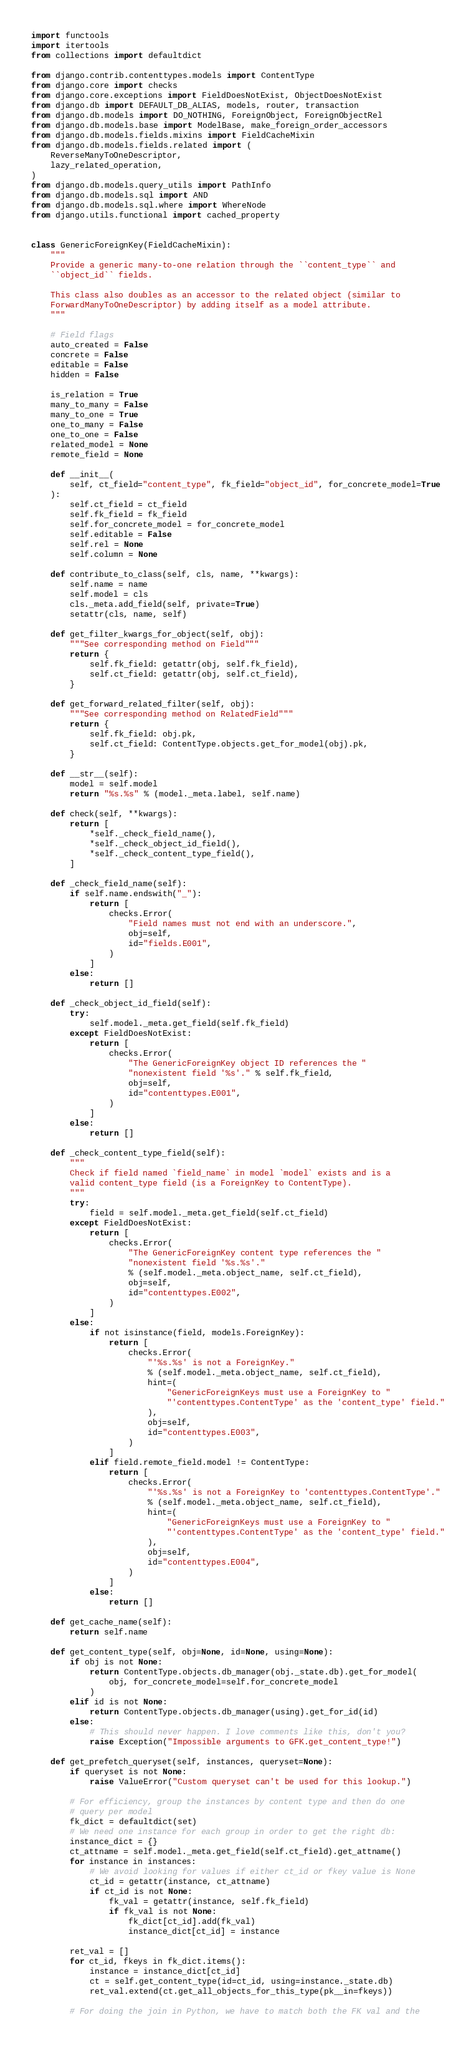<code> <loc_0><loc_0><loc_500><loc_500><_Python_>import functools
import itertools
from collections import defaultdict

from django.contrib.contenttypes.models import ContentType
from django.core import checks
from django.core.exceptions import FieldDoesNotExist, ObjectDoesNotExist
from django.db import DEFAULT_DB_ALIAS, models, router, transaction
from django.db.models import DO_NOTHING, ForeignObject, ForeignObjectRel
from django.db.models.base import ModelBase, make_foreign_order_accessors
from django.db.models.fields.mixins import FieldCacheMixin
from django.db.models.fields.related import (
    ReverseManyToOneDescriptor,
    lazy_related_operation,
)
from django.db.models.query_utils import PathInfo
from django.db.models.sql import AND
from django.db.models.sql.where import WhereNode
from django.utils.functional import cached_property


class GenericForeignKey(FieldCacheMixin):
    """
    Provide a generic many-to-one relation through the ``content_type`` and
    ``object_id`` fields.

    This class also doubles as an accessor to the related object (similar to
    ForwardManyToOneDescriptor) by adding itself as a model attribute.
    """

    # Field flags
    auto_created = False
    concrete = False
    editable = False
    hidden = False

    is_relation = True
    many_to_many = False
    many_to_one = True
    one_to_many = False
    one_to_one = False
    related_model = None
    remote_field = None

    def __init__(
        self, ct_field="content_type", fk_field="object_id", for_concrete_model=True
    ):
        self.ct_field = ct_field
        self.fk_field = fk_field
        self.for_concrete_model = for_concrete_model
        self.editable = False
        self.rel = None
        self.column = None

    def contribute_to_class(self, cls, name, **kwargs):
        self.name = name
        self.model = cls
        cls._meta.add_field(self, private=True)
        setattr(cls, name, self)

    def get_filter_kwargs_for_object(self, obj):
        """See corresponding method on Field"""
        return {
            self.fk_field: getattr(obj, self.fk_field),
            self.ct_field: getattr(obj, self.ct_field),
        }

    def get_forward_related_filter(self, obj):
        """See corresponding method on RelatedField"""
        return {
            self.fk_field: obj.pk,
            self.ct_field: ContentType.objects.get_for_model(obj).pk,
        }

    def __str__(self):
        model = self.model
        return "%s.%s" % (model._meta.label, self.name)

    def check(self, **kwargs):
        return [
            *self._check_field_name(),
            *self._check_object_id_field(),
            *self._check_content_type_field(),
        ]

    def _check_field_name(self):
        if self.name.endswith("_"):
            return [
                checks.Error(
                    "Field names must not end with an underscore.",
                    obj=self,
                    id="fields.E001",
                )
            ]
        else:
            return []

    def _check_object_id_field(self):
        try:
            self.model._meta.get_field(self.fk_field)
        except FieldDoesNotExist:
            return [
                checks.Error(
                    "The GenericForeignKey object ID references the "
                    "nonexistent field '%s'." % self.fk_field,
                    obj=self,
                    id="contenttypes.E001",
                )
            ]
        else:
            return []

    def _check_content_type_field(self):
        """
        Check if field named `field_name` in model `model` exists and is a
        valid content_type field (is a ForeignKey to ContentType).
        """
        try:
            field = self.model._meta.get_field(self.ct_field)
        except FieldDoesNotExist:
            return [
                checks.Error(
                    "The GenericForeignKey content type references the "
                    "nonexistent field '%s.%s'."
                    % (self.model._meta.object_name, self.ct_field),
                    obj=self,
                    id="contenttypes.E002",
                )
            ]
        else:
            if not isinstance(field, models.ForeignKey):
                return [
                    checks.Error(
                        "'%s.%s' is not a ForeignKey."
                        % (self.model._meta.object_name, self.ct_field),
                        hint=(
                            "GenericForeignKeys must use a ForeignKey to "
                            "'contenttypes.ContentType' as the 'content_type' field."
                        ),
                        obj=self,
                        id="contenttypes.E003",
                    )
                ]
            elif field.remote_field.model != ContentType:
                return [
                    checks.Error(
                        "'%s.%s' is not a ForeignKey to 'contenttypes.ContentType'."
                        % (self.model._meta.object_name, self.ct_field),
                        hint=(
                            "GenericForeignKeys must use a ForeignKey to "
                            "'contenttypes.ContentType' as the 'content_type' field."
                        ),
                        obj=self,
                        id="contenttypes.E004",
                    )
                ]
            else:
                return []

    def get_cache_name(self):
        return self.name

    def get_content_type(self, obj=None, id=None, using=None):
        if obj is not None:
            return ContentType.objects.db_manager(obj._state.db).get_for_model(
                obj, for_concrete_model=self.for_concrete_model
            )
        elif id is not None:
            return ContentType.objects.db_manager(using).get_for_id(id)
        else:
            # This should never happen. I love comments like this, don't you?
            raise Exception("Impossible arguments to GFK.get_content_type!")

    def get_prefetch_queryset(self, instances, queryset=None):
        if queryset is not None:
            raise ValueError("Custom queryset can't be used for this lookup.")

        # For efficiency, group the instances by content type and then do one
        # query per model
        fk_dict = defaultdict(set)
        # We need one instance for each group in order to get the right db:
        instance_dict = {}
        ct_attname = self.model._meta.get_field(self.ct_field).get_attname()
        for instance in instances:
            # We avoid looking for values if either ct_id or fkey value is None
            ct_id = getattr(instance, ct_attname)
            if ct_id is not None:
                fk_val = getattr(instance, self.fk_field)
                if fk_val is not None:
                    fk_dict[ct_id].add(fk_val)
                    instance_dict[ct_id] = instance

        ret_val = []
        for ct_id, fkeys in fk_dict.items():
            instance = instance_dict[ct_id]
            ct = self.get_content_type(id=ct_id, using=instance._state.db)
            ret_val.extend(ct.get_all_objects_for_this_type(pk__in=fkeys))

        # For doing the join in Python, we have to match both the FK val and the</code> 